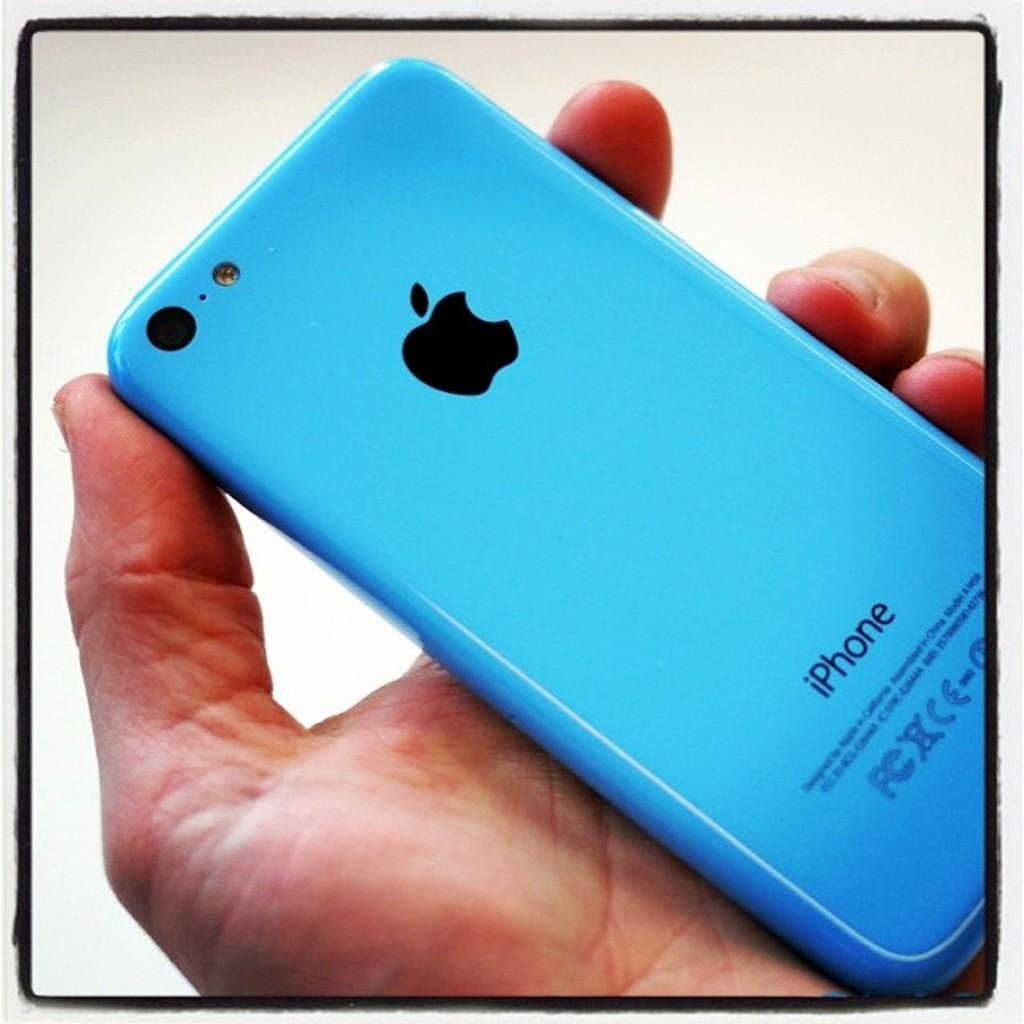<image>
Relay a brief, clear account of the picture shown. A person is holding an Apple iPhone with a blue colored case. 